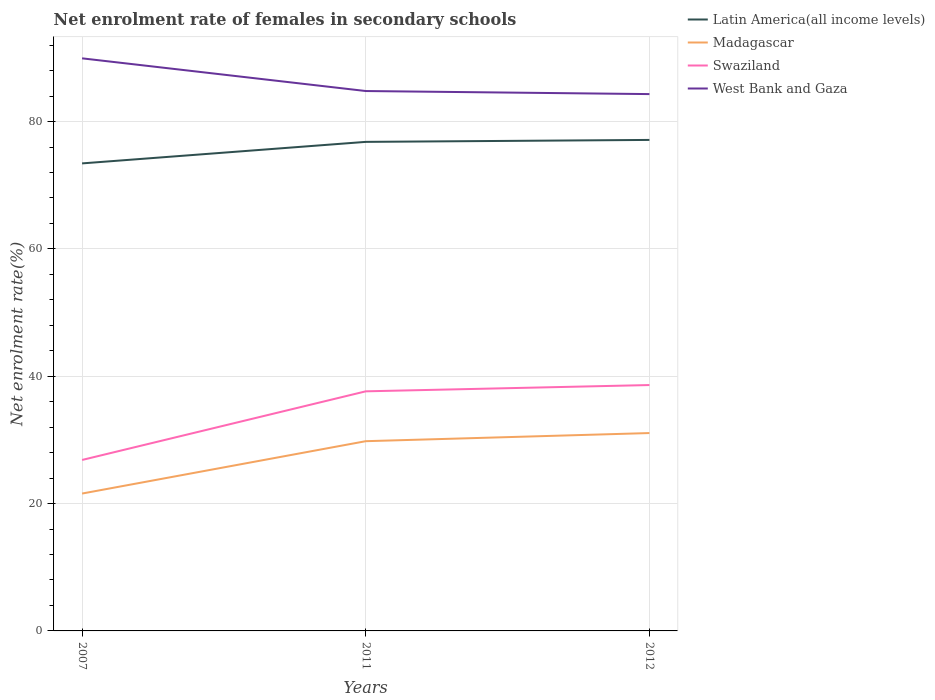Does the line corresponding to Madagascar intersect with the line corresponding to West Bank and Gaza?
Provide a succinct answer. No. Is the number of lines equal to the number of legend labels?
Make the answer very short. Yes. Across all years, what is the maximum net enrolment rate of females in secondary schools in Swaziland?
Make the answer very short. 26.85. What is the total net enrolment rate of females in secondary schools in West Bank and Gaza in the graph?
Give a very brief answer. 5.62. What is the difference between the highest and the second highest net enrolment rate of females in secondary schools in Madagascar?
Provide a succinct answer. 9.5. How many lines are there?
Your answer should be very brief. 4. How many years are there in the graph?
Ensure brevity in your answer.  3. Where does the legend appear in the graph?
Give a very brief answer. Top right. What is the title of the graph?
Give a very brief answer. Net enrolment rate of females in secondary schools. What is the label or title of the Y-axis?
Offer a terse response. Net enrolment rate(%). What is the Net enrolment rate(%) of Latin America(all income levels) in 2007?
Give a very brief answer. 73.43. What is the Net enrolment rate(%) of Madagascar in 2007?
Your answer should be compact. 21.57. What is the Net enrolment rate(%) in Swaziland in 2007?
Your response must be concise. 26.85. What is the Net enrolment rate(%) in West Bank and Gaza in 2007?
Offer a terse response. 89.92. What is the Net enrolment rate(%) in Latin America(all income levels) in 2011?
Make the answer very short. 76.8. What is the Net enrolment rate(%) in Madagascar in 2011?
Offer a terse response. 29.8. What is the Net enrolment rate(%) in Swaziland in 2011?
Make the answer very short. 37.63. What is the Net enrolment rate(%) in West Bank and Gaza in 2011?
Your answer should be compact. 84.79. What is the Net enrolment rate(%) in Latin America(all income levels) in 2012?
Offer a terse response. 77.11. What is the Net enrolment rate(%) of Madagascar in 2012?
Your response must be concise. 31.08. What is the Net enrolment rate(%) of Swaziland in 2012?
Your answer should be very brief. 38.61. What is the Net enrolment rate(%) of West Bank and Gaza in 2012?
Give a very brief answer. 84.31. Across all years, what is the maximum Net enrolment rate(%) in Latin America(all income levels)?
Your response must be concise. 77.11. Across all years, what is the maximum Net enrolment rate(%) of Madagascar?
Your answer should be very brief. 31.08. Across all years, what is the maximum Net enrolment rate(%) of Swaziland?
Keep it short and to the point. 38.61. Across all years, what is the maximum Net enrolment rate(%) in West Bank and Gaza?
Your answer should be compact. 89.92. Across all years, what is the minimum Net enrolment rate(%) in Latin America(all income levels)?
Keep it short and to the point. 73.43. Across all years, what is the minimum Net enrolment rate(%) of Madagascar?
Ensure brevity in your answer.  21.57. Across all years, what is the minimum Net enrolment rate(%) of Swaziland?
Provide a succinct answer. 26.85. Across all years, what is the minimum Net enrolment rate(%) in West Bank and Gaza?
Offer a very short reply. 84.31. What is the total Net enrolment rate(%) of Latin America(all income levels) in the graph?
Make the answer very short. 227.34. What is the total Net enrolment rate(%) in Madagascar in the graph?
Make the answer very short. 82.45. What is the total Net enrolment rate(%) in Swaziland in the graph?
Offer a terse response. 103.09. What is the total Net enrolment rate(%) in West Bank and Gaza in the graph?
Keep it short and to the point. 259.02. What is the difference between the Net enrolment rate(%) of Latin America(all income levels) in 2007 and that in 2011?
Provide a short and direct response. -3.38. What is the difference between the Net enrolment rate(%) of Madagascar in 2007 and that in 2011?
Your answer should be very brief. -8.22. What is the difference between the Net enrolment rate(%) in Swaziland in 2007 and that in 2011?
Offer a very short reply. -10.78. What is the difference between the Net enrolment rate(%) in West Bank and Gaza in 2007 and that in 2011?
Ensure brevity in your answer.  5.13. What is the difference between the Net enrolment rate(%) in Latin America(all income levels) in 2007 and that in 2012?
Offer a terse response. -3.69. What is the difference between the Net enrolment rate(%) of Madagascar in 2007 and that in 2012?
Provide a short and direct response. -9.5. What is the difference between the Net enrolment rate(%) in Swaziland in 2007 and that in 2012?
Your response must be concise. -11.76. What is the difference between the Net enrolment rate(%) in West Bank and Gaza in 2007 and that in 2012?
Your answer should be very brief. 5.62. What is the difference between the Net enrolment rate(%) of Latin America(all income levels) in 2011 and that in 2012?
Offer a very short reply. -0.31. What is the difference between the Net enrolment rate(%) in Madagascar in 2011 and that in 2012?
Offer a terse response. -1.28. What is the difference between the Net enrolment rate(%) in Swaziland in 2011 and that in 2012?
Your answer should be very brief. -0.99. What is the difference between the Net enrolment rate(%) of West Bank and Gaza in 2011 and that in 2012?
Ensure brevity in your answer.  0.48. What is the difference between the Net enrolment rate(%) of Latin America(all income levels) in 2007 and the Net enrolment rate(%) of Madagascar in 2011?
Keep it short and to the point. 43.63. What is the difference between the Net enrolment rate(%) in Latin America(all income levels) in 2007 and the Net enrolment rate(%) in Swaziland in 2011?
Make the answer very short. 35.8. What is the difference between the Net enrolment rate(%) in Latin America(all income levels) in 2007 and the Net enrolment rate(%) in West Bank and Gaza in 2011?
Offer a very short reply. -11.37. What is the difference between the Net enrolment rate(%) in Madagascar in 2007 and the Net enrolment rate(%) in Swaziland in 2011?
Your answer should be very brief. -16.05. What is the difference between the Net enrolment rate(%) of Madagascar in 2007 and the Net enrolment rate(%) of West Bank and Gaza in 2011?
Provide a short and direct response. -63.22. What is the difference between the Net enrolment rate(%) of Swaziland in 2007 and the Net enrolment rate(%) of West Bank and Gaza in 2011?
Your response must be concise. -57.94. What is the difference between the Net enrolment rate(%) in Latin America(all income levels) in 2007 and the Net enrolment rate(%) in Madagascar in 2012?
Ensure brevity in your answer.  42.35. What is the difference between the Net enrolment rate(%) in Latin America(all income levels) in 2007 and the Net enrolment rate(%) in Swaziland in 2012?
Your answer should be compact. 34.81. What is the difference between the Net enrolment rate(%) of Latin America(all income levels) in 2007 and the Net enrolment rate(%) of West Bank and Gaza in 2012?
Keep it short and to the point. -10.88. What is the difference between the Net enrolment rate(%) in Madagascar in 2007 and the Net enrolment rate(%) in Swaziland in 2012?
Provide a succinct answer. -17.04. What is the difference between the Net enrolment rate(%) in Madagascar in 2007 and the Net enrolment rate(%) in West Bank and Gaza in 2012?
Give a very brief answer. -62.73. What is the difference between the Net enrolment rate(%) in Swaziland in 2007 and the Net enrolment rate(%) in West Bank and Gaza in 2012?
Your answer should be compact. -57.46. What is the difference between the Net enrolment rate(%) in Latin America(all income levels) in 2011 and the Net enrolment rate(%) in Madagascar in 2012?
Your response must be concise. 45.73. What is the difference between the Net enrolment rate(%) of Latin America(all income levels) in 2011 and the Net enrolment rate(%) of Swaziland in 2012?
Keep it short and to the point. 38.19. What is the difference between the Net enrolment rate(%) of Latin America(all income levels) in 2011 and the Net enrolment rate(%) of West Bank and Gaza in 2012?
Make the answer very short. -7.5. What is the difference between the Net enrolment rate(%) in Madagascar in 2011 and the Net enrolment rate(%) in Swaziland in 2012?
Offer a terse response. -8.82. What is the difference between the Net enrolment rate(%) in Madagascar in 2011 and the Net enrolment rate(%) in West Bank and Gaza in 2012?
Offer a terse response. -54.51. What is the difference between the Net enrolment rate(%) in Swaziland in 2011 and the Net enrolment rate(%) in West Bank and Gaza in 2012?
Your response must be concise. -46.68. What is the average Net enrolment rate(%) in Latin America(all income levels) per year?
Provide a short and direct response. 75.78. What is the average Net enrolment rate(%) of Madagascar per year?
Your answer should be very brief. 27.48. What is the average Net enrolment rate(%) of Swaziland per year?
Make the answer very short. 34.36. What is the average Net enrolment rate(%) in West Bank and Gaza per year?
Ensure brevity in your answer.  86.34. In the year 2007, what is the difference between the Net enrolment rate(%) in Latin America(all income levels) and Net enrolment rate(%) in Madagascar?
Provide a succinct answer. 51.85. In the year 2007, what is the difference between the Net enrolment rate(%) of Latin America(all income levels) and Net enrolment rate(%) of Swaziland?
Ensure brevity in your answer.  46.58. In the year 2007, what is the difference between the Net enrolment rate(%) in Latin America(all income levels) and Net enrolment rate(%) in West Bank and Gaza?
Your answer should be very brief. -16.5. In the year 2007, what is the difference between the Net enrolment rate(%) in Madagascar and Net enrolment rate(%) in Swaziland?
Your answer should be compact. -5.28. In the year 2007, what is the difference between the Net enrolment rate(%) of Madagascar and Net enrolment rate(%) of West Bank and Gaza?
Offer a terse response. -68.35. In the year 2007, what is the difference between the Net enrolment rate(%) of Swaziland and Net enrolment rate(%) of West Bank and Gaza?
Offer a very short reply. -63.08. In the year 2011, what is the difference between the Net enrolment rate(%) of Latin America(all income levels) and Net enrolment rate(%) of Madagascar?
Keep it short and to the point. 47.01. In the year 2011, what is the difference between the Net enrolment rate(%) of Latin America(all income levels) and Net enrolment rate(%) of Swaziland?
Your answer should be very brief. 39.18. In the year 2011, what is the difference between the Net enrolment rate(%) of Latin America(all income levels) and Net enrolment rate(%) of West Bank and Gaza?
Your answer should be very brief. -7.99. In the year 2011, what is the difference between the Net enrolment rate(%) of Madagascar and Net enrolment rate(%) of Swaziland?
Offer a very short reply. -7.83. In the year 2011, what is the difference between the Net enrolment rate(%) in Madagascar and Net enrolment rate(%) in West Bank and Gaza?
Your answer should be very brief. -54.99. In the year 2011, what is the difference between the Net enrolment rate(%) of Swaziland and Net enrolment rate(%) of West Bank and Gaza?
Provide a short and direct response. -47.16. In the year 2012, what is the difference between the Net enrolment rate(%) in Latin America(all income levels) and Net enrolment rate(%) in Madagascar?
Provide a succinct answer. 46.04. In the year 2012, what is the difference between the Net enrolment rate(%) of Latin America(all income levels) and Net enrolment rate(%) of Swaziland?
Ensure brevity in your answer.  38.5. In the year 2012, what is the difference between the Net enrolment rate(%) of Latin America(all income levels) and Net enrolment rate(%) of West Bank and Gaza?
Provide a short and direct response. -7.2. In the year 2012, what is the difference between the Net enrolment rate(%) of Madagascar and Net enrolment rate(%) of Swaziland?
Offer a terse response. -7.54. In the year 2012, what is the difference between the Net enrolment rate(%) in Madagascar and Net enrolment rate(%) in West Bank and Gaza?
Your response must be concise. -53.23. In the year 2012, what is the difference between the Net enrolment rate(%) of Swaziland and Net enrolment rate(%) of West Bank and Gaza?
Offer a very short reply. -45.69. What is the ratio of the Net enrolment rate(%) in Latin America(all income levels) in 2007 to that in 2011?
Your response must be concise. 0.96. What is the ratio of the Net enrolment rate(%) in Madagascar in 2007 to that in 2011?
Offer a terse response. 0.72. What is the ratio of the Net enrolment rate(%) of Swaziland in 2007 to that in 2011?
Ensure brevity in your answer.  0.71. What is the ratio of the Net enrolment rate(%) in West Bank and Gaza in 2007 to that in 2011?
Provide a short and direct response. 1.06. What is the ratio of the Net enrolment rate(%) in Latin America(all income levels) in 2007 to that in 2012?
Provide a short and direct response. 0.95. What is the ratio of the Net enrolment rate(%) of Madagascar in 2007 to that in 2012?
Ensure brevity in your answer.  0.69. What is the ratio of the Net enrolment rate(%) of Swaziland in 2007 to that in 2012?
Offer a very short reply. 0.7. What is the ratio of the Net enrolment rate(%) in West Bank and Gaza in 2007 to that in 2012?
Make the answer very short. 1.07. What is the ratio of the Net enrolment rate(%) in Madagascar in 2011 to that in 2012?
Your answer should be compact. 0.96. What is the ratio of the Net enrolment rate(%) of Swaziland in 2011 to that in 2012?
Offer a very short reply. 0.97. What is the ratio of the Net enrolment rate(%) in West Bank and Gaza in 2011 to that in 2012?
Give a very brief answer. 1.01. What is the difference between the highest and the second highest Net enrolment rate(%) in Latin America(all income levels)?
Offer a terse response. 0.31. What is the difference between the highest and the second highest Net enrolment rate(%) in Madagascar?
Your answer should be very brief. 1.28. What is the difference between the highest and the second highest Net enrolment rate(%) in Swaziland?
Keep it short and to the point. 0.99. What is the difference between the highest and the second highest Net enrolment rate(%) of West Bank and Gaza?
Provide a short and direct response. 5.13. What is the difference between the highest and the lowest Net enrolment rate(%) in Latin America(all income levels)?
Offer a very short reply. 3.69. What is the difference between the highest and the lowest Net enrolment rate(%) in Madagascar?
Offer a terse response. 9.5. What is the difference between the highest and the lowest Net enrolment rate(%) in Swaziland?
Ensure brevity in your answer.  11.76. What is the difference between the highest and the lowest Net enrolment rate(%) of West Bank and Gaza?
Offer a terse response. 5.62. 